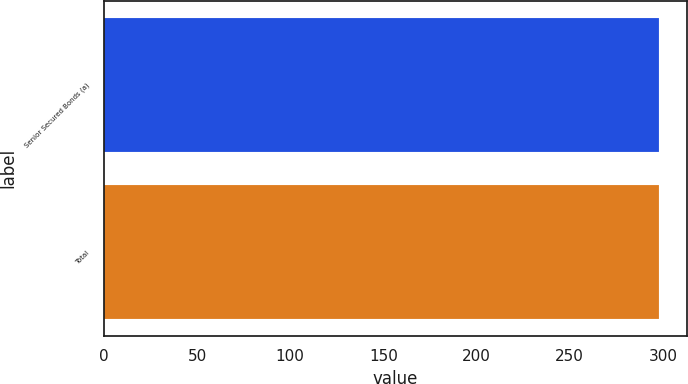<chart> <loc_0><loc_0><loc_500><loc_500><bar_chart><fcel>Senior Secured Bonds (a)<fcel>Total<nl><fcel>298<fcel>298.1<nl></chart> 